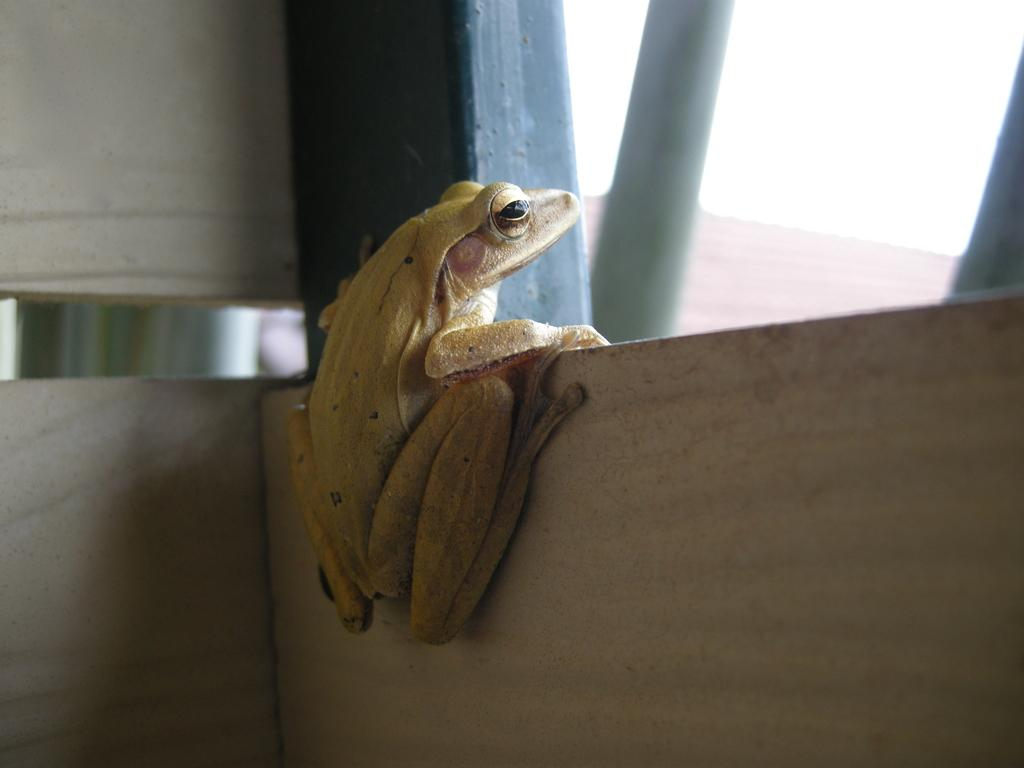What type of animal is in the image? There is a frog in the image. What color is the frog? The frog is cream-colored. What is the frog doing in the image? The frog is climbing a marble surface. What can be seen at the top of the image? The sky is visible at the top of the image. What type of experience does the frog have with the substance in the image? There is no substance mentioned in the image, and the frog's experience cannot be determined from the image alone. 